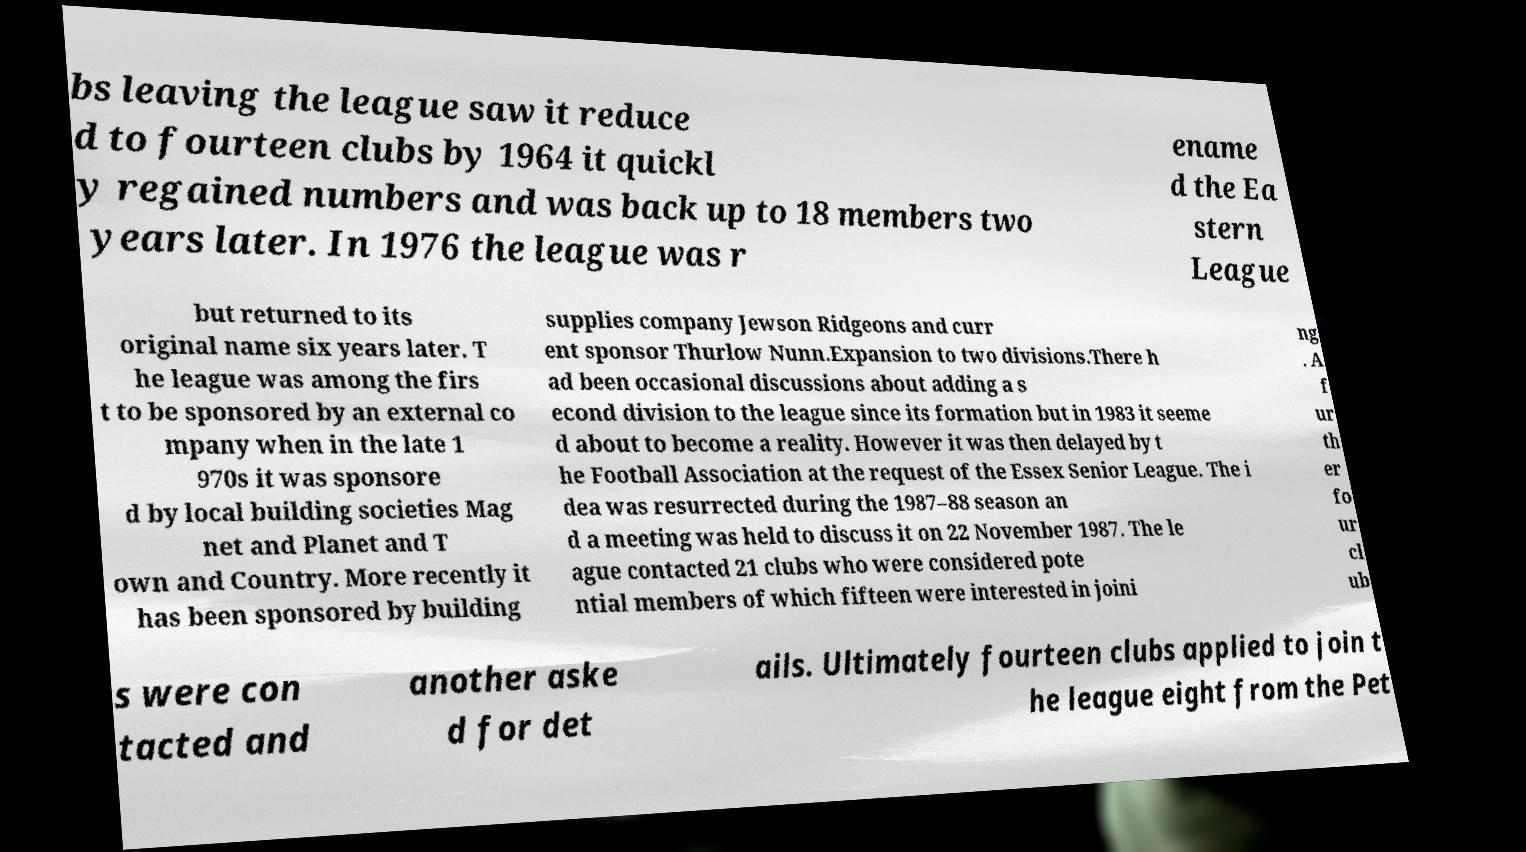Could you extract and type out the text from this image? bs leaving the league saw it reduce d to fourteen clubs by 1964 it quickl y regained numbers and was back up to 18 members two years later. In 1976 the league was r ename d the Ea stern League but returned to its original name six years later. T he league was among the firs t to be sponsored by an external co mpany when in the late 1 970s it was sponsore d by local building societies Mag net and Planet and T own and Country. More recently it has been sponsored by building supplies company Jewson Ridgeons and curr ent sponsor Thurlow Nunn.Expansion to two divisions.There h ad been occasional discussions about adding a s econd division to the league since its formation but in 1983 it seeme d about to become a reality. However it was then delayed by t he Football Association at the request of the Essex Senior League. The i dea was resurrected during the 1987–88 season an d a meeting was held to discuss it on 22 November 1987. The le ague contacted 21 clubs who were considered pote ntial members of which fifteen were interested in joini ng . A f ur th er fo ur cl ub s were con tacted and another aske d for det ails. Ultimately fourteen clubs applied to join t he league eight from the Pet 